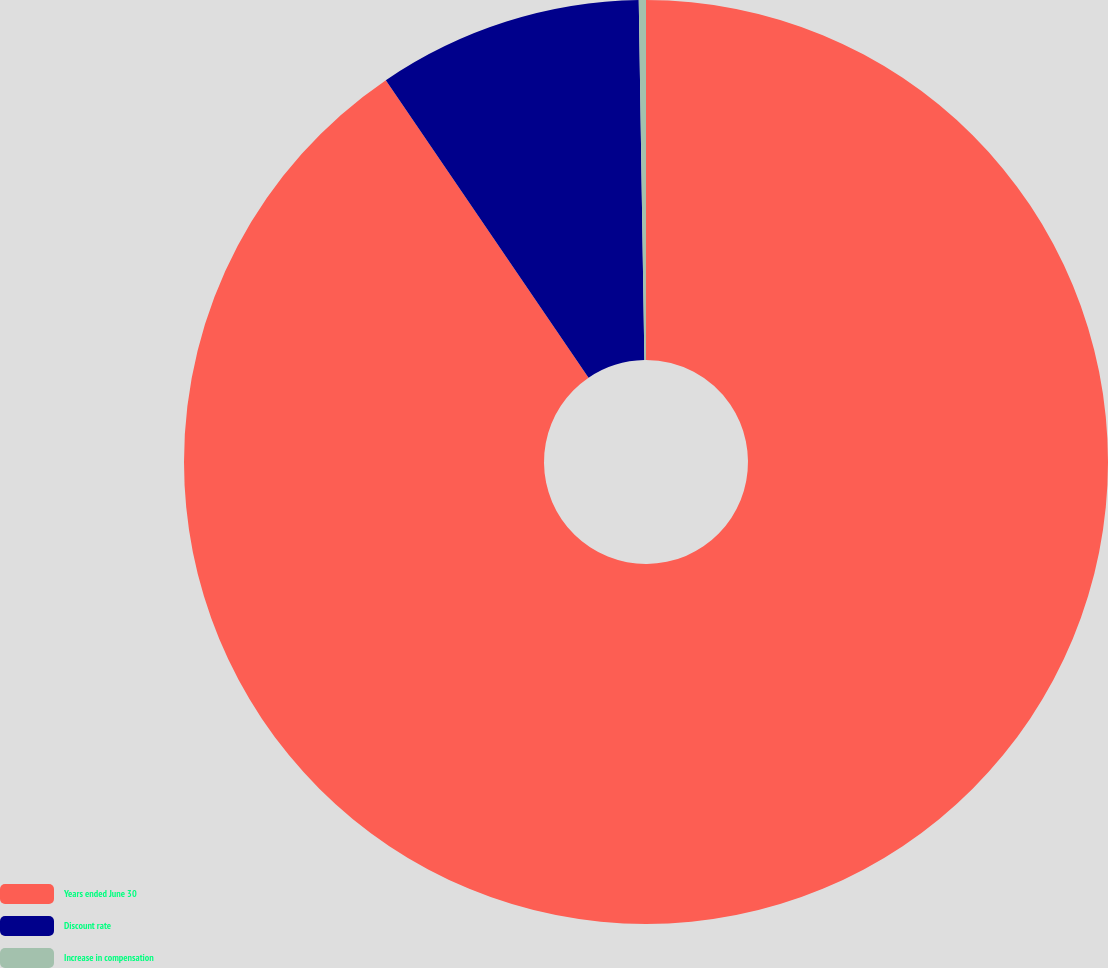Convert chart to OTSL. <chart><loc_0><loc_0><loc_500><loc_500><pie_chart><fcel>Years ended June 30<fcel>Discount rate<fcel>Increase in compensation<nl><fcel>90.48%<fcel>9.27%<fcel>0.25%<nl></chart> 